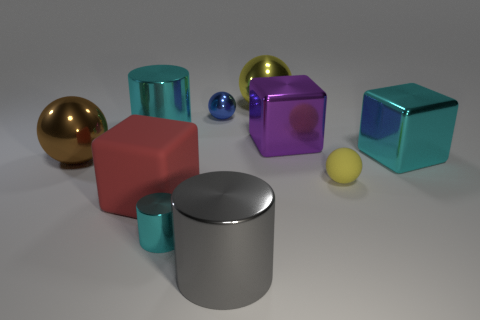Is the size of the cyan cylinder that is in front of the red block the same as the big brown ball? While it might initially appear that the cyan cylinder is smaller, without precise measurements it's difficult to ascertain if it is exactly the same size as the brown ball. However, from this angle and considering perspective, the cyan cylinder seems to be of a smaller dimension than the brown ball. 